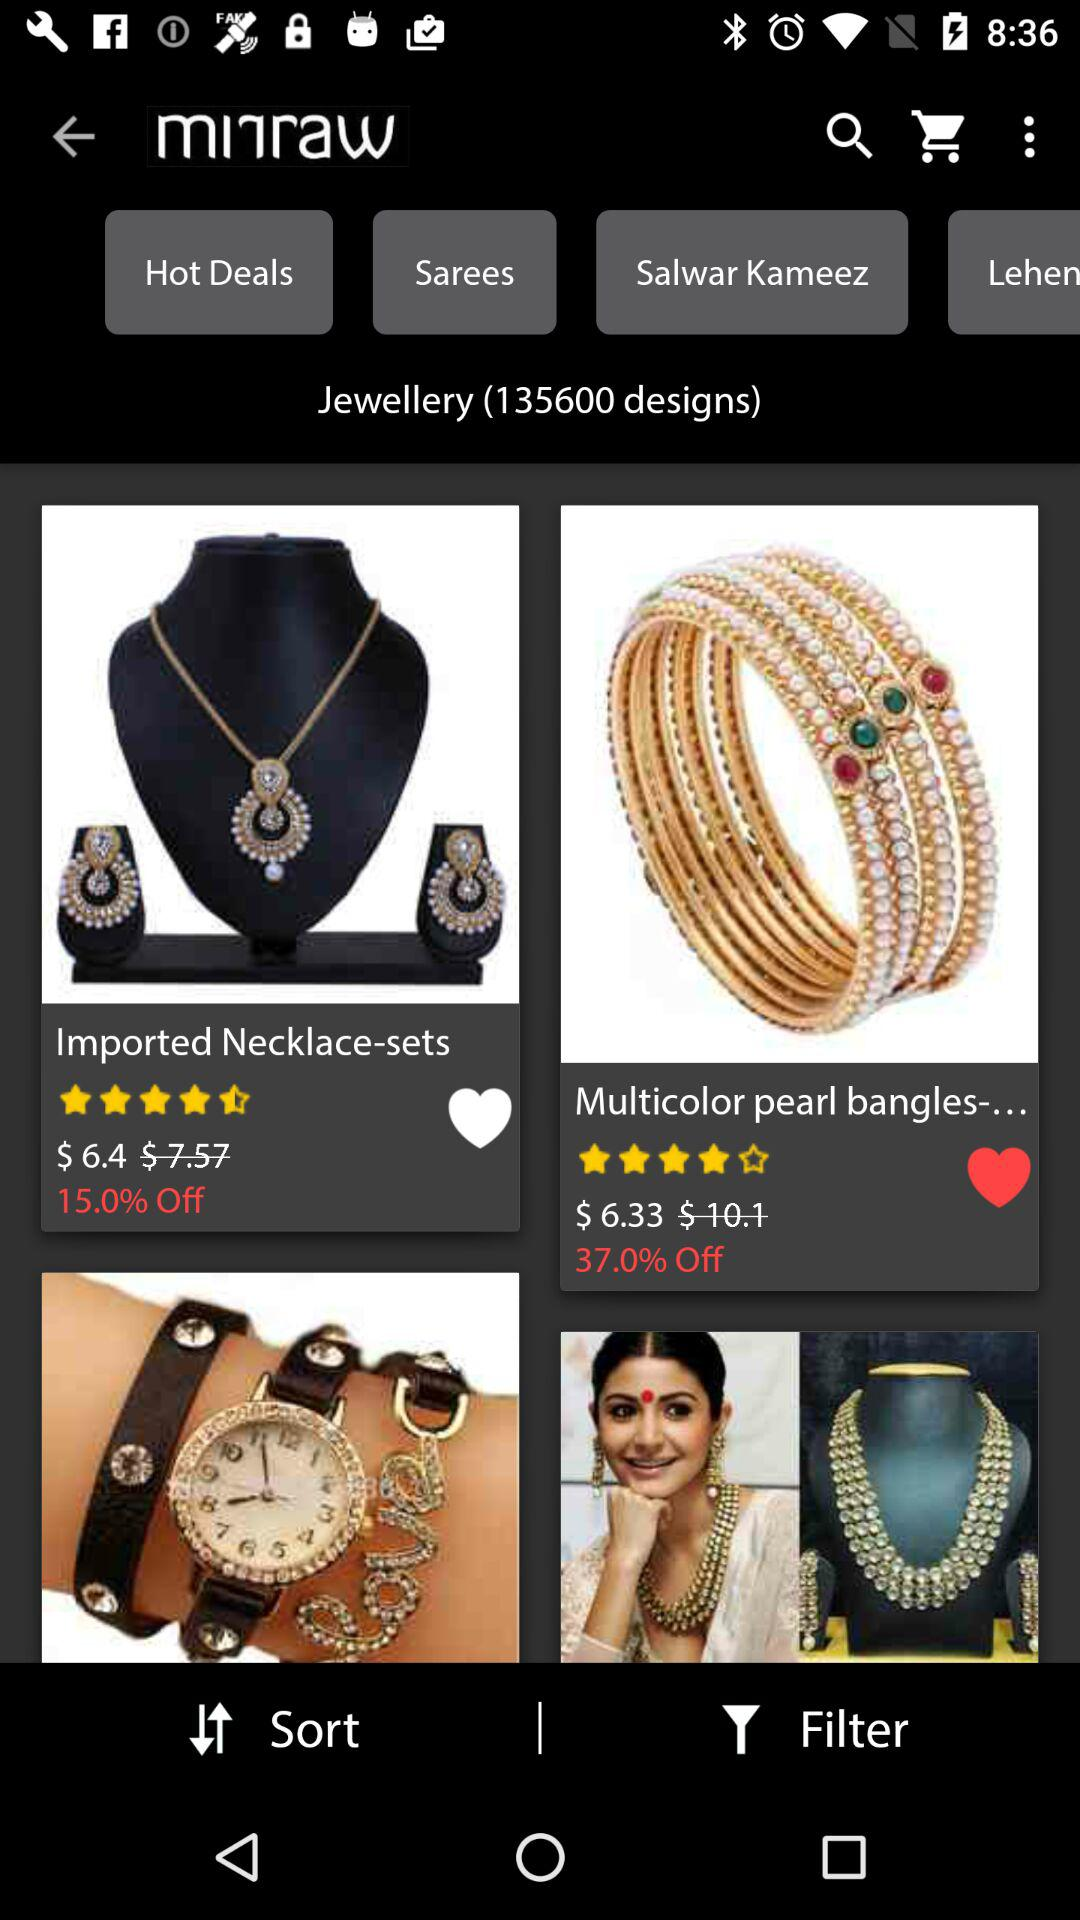How many designs in total are there? There are 135600 designs. 